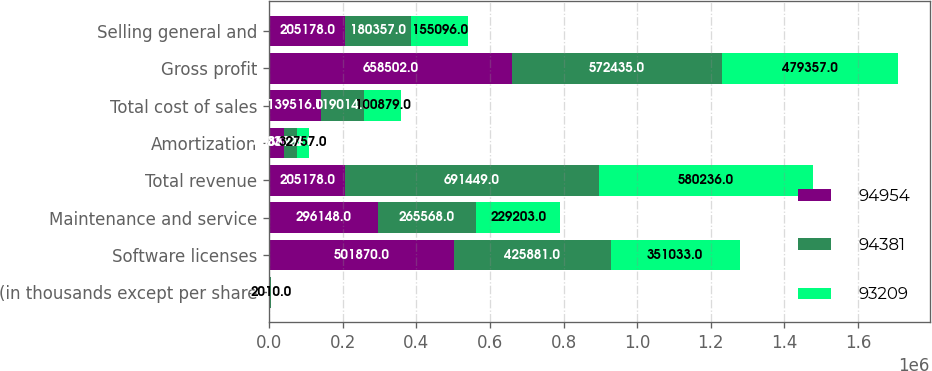<chart> <loc_0><loc_0><loc_500><loc_500><stacked_bar_chart><ecel><fcel>(in thousands except per share<fcel>Software licenses<fcel>Maintenance and service<fcel>Total revenue<fcel>Amortization<fcel>Total cost of sales<fcel>Gross profit<fcel>Selling general and<nl><fcel>94954<fcel>2012<fcel>501870<fcel>296148<fcel>205178<fcel>40889<fcel>139516<fcel>658502<fcel>205178<nl><fcel>94381<fcel>2011<fcel>425881<fcel>265568<fcel>691449<fcel>33728<fcel>119014<fcel>572435<fcel>180357<nl><fcel>93209<fcel>2010<fcel>351033<fcel>229203<fcel>580236<fcel>32757<fcel>100879<fcel>479357<fcel>155096<nl></chart> 